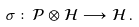<formula> <loc_0><loc_0><loc_500><loc_500>\sigma \colon \mathcal { P } \otimes \mathcal { H } \longrightarrow \mathcal { H } \, .</formula> 